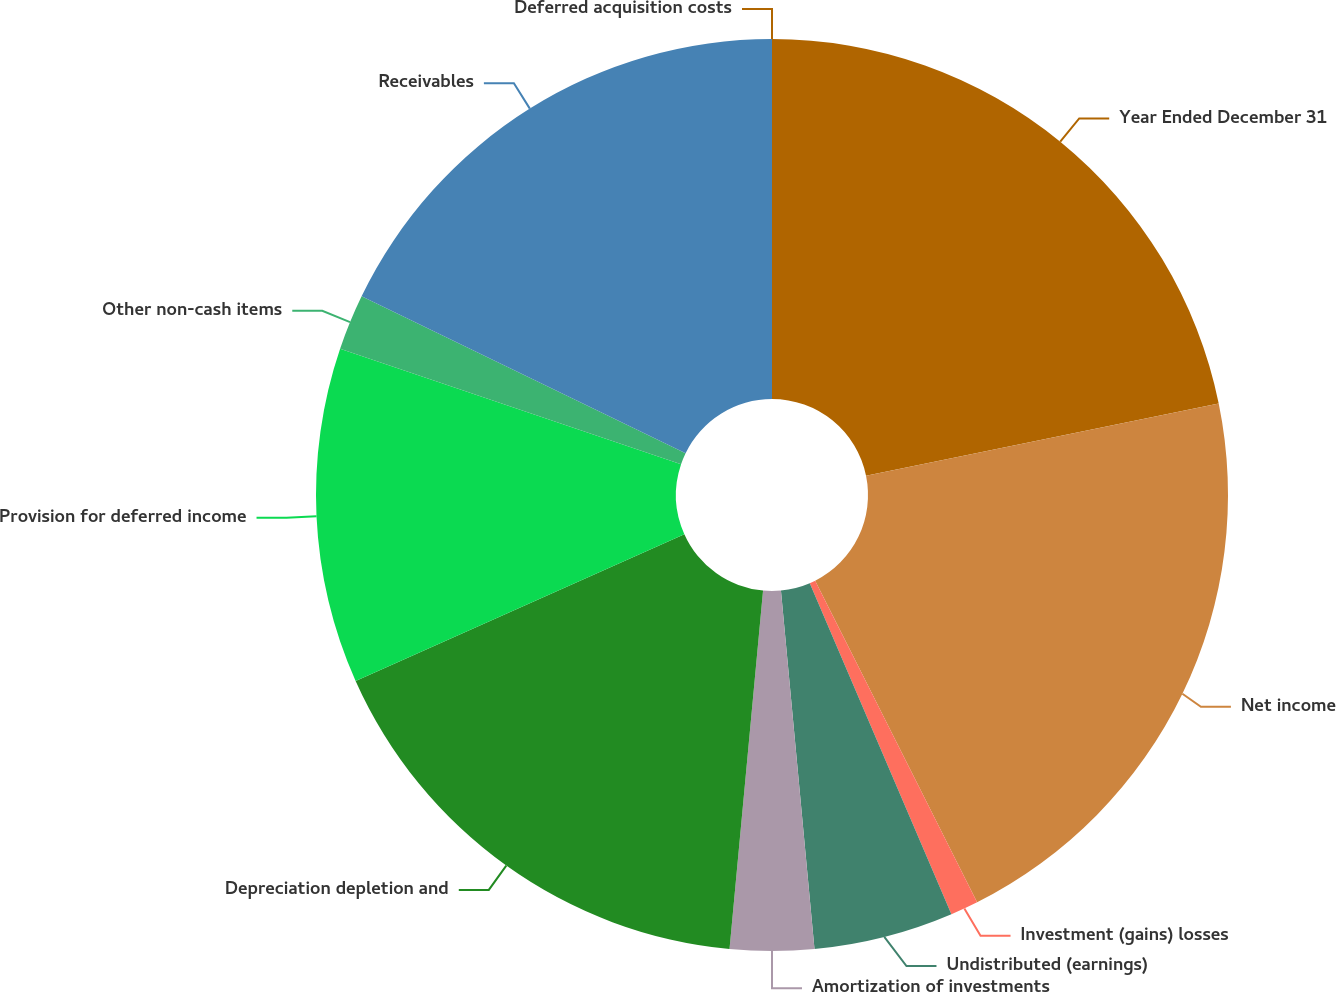<chart> <loc_0><loc_0><loc_500><loc_500><pie_chart><fcel>Year Ended December 31<fcel>Net income<fcel>Investment (gains) losses<fcel>Undistributed (earnings)<fcel>Amortization of investments<fcel>Depreciation depletion and<fcel>Provision for deferred income<fcel>Other non-cash items<fcel>Receivables<fcel>Deferred acquisition costs<nl><fcel>21.78%<fcel>20.79%<fcel>0.99%<fcel>4.95%<fcel>2.97%<fcel>16.83%<fcel>11.88%<fcel>1.98%<fcel>17.82%<fcel>0.0%<nl></chart> 